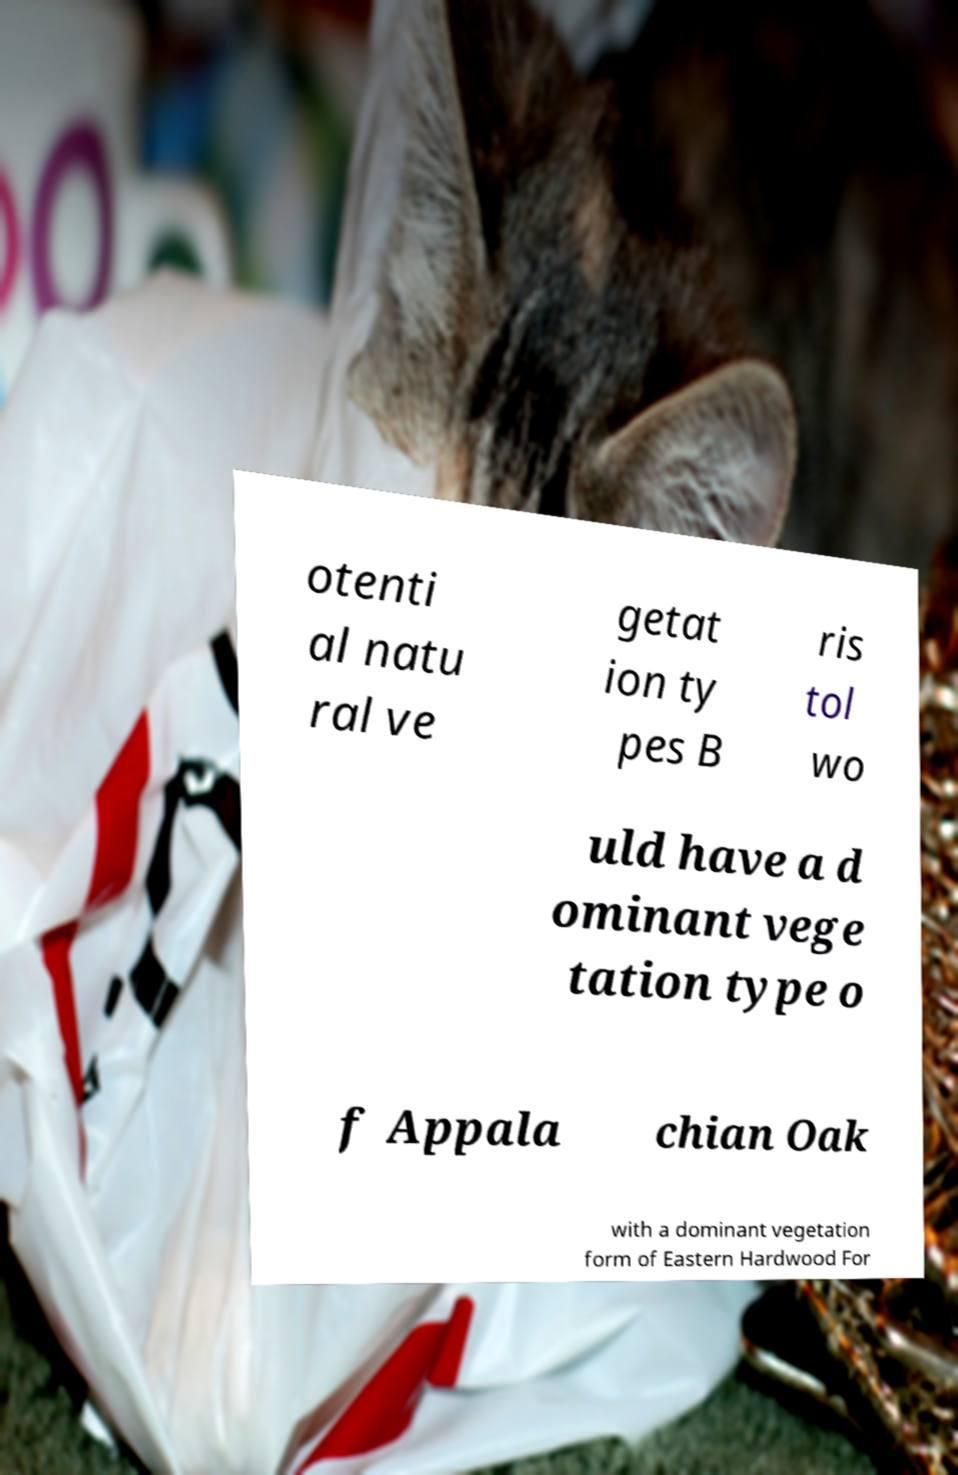There's text embedded in this image that I need extracted. Can you transcribe it verbatim? otenti al natu ral ve getat ion ty pes B ris tol wo uld have a d ominant vege tation type o f Appala chian Oak with a dominant vegetation form of Eastern Hardwood For 